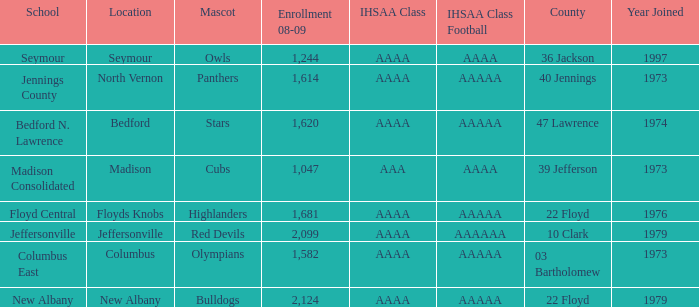What's the IHSAA Class when the school is Seymour? AAAA. 